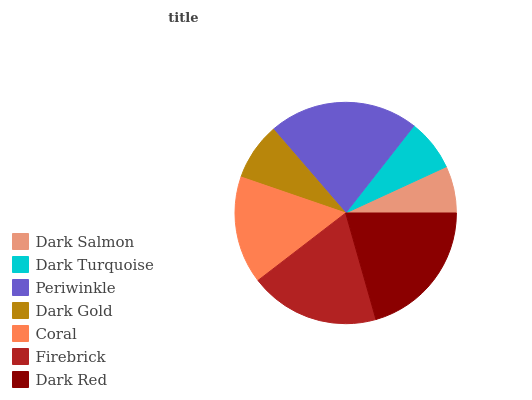Is Dark Salmon the minimum?
Answer yes or no. Yes. Is Periwinkle the maximum?
Answer yes or no. Yes. Is Dark Turquoise the minimum?
Answer yes or no. No. Is Dark Turquoise the maximum?
Answer yes or no. No. Is Dark Turquoise greater than Dark Salmon?
Answer yes or no. Yes. Is Dark Salmon less than Dark Turquoise?
Answer yes or no. Yes. Is Dark Salmon greater than Dark Turquoise?
Answer yes or no. No. Is Dark Turquoise less than Dark Salmon?
Answer yes or no. No. Is Coral the high median?
Answer yes or no. Yes. Is Coral the low median?
Answer yes or no. Yes. Is Firebrick the high median?
Answer yes or no. No. Is Periwinkle the low median?
Answer yes or no. No. 